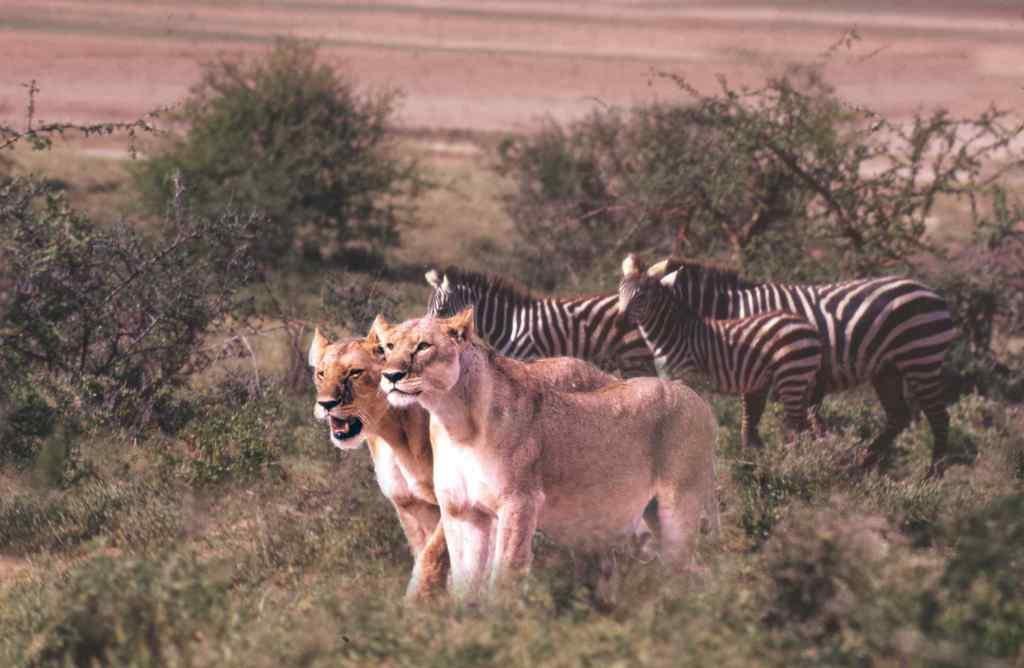What animals can be seen in the image? There are two lions and three zebras in the image. What type of vegetation is visible in the image? There is grass and plants visible in the image. Can you describe the quality of the image? The image is slightly blurred. What type of hen can be seen interacting with the grass in the image? There is no hen present in the image; it features two lions and three zebras. What achievements can be attributed to the achiever in the image? There is no achiever present in the image; it features two lions and three zebras in a natural setting. 